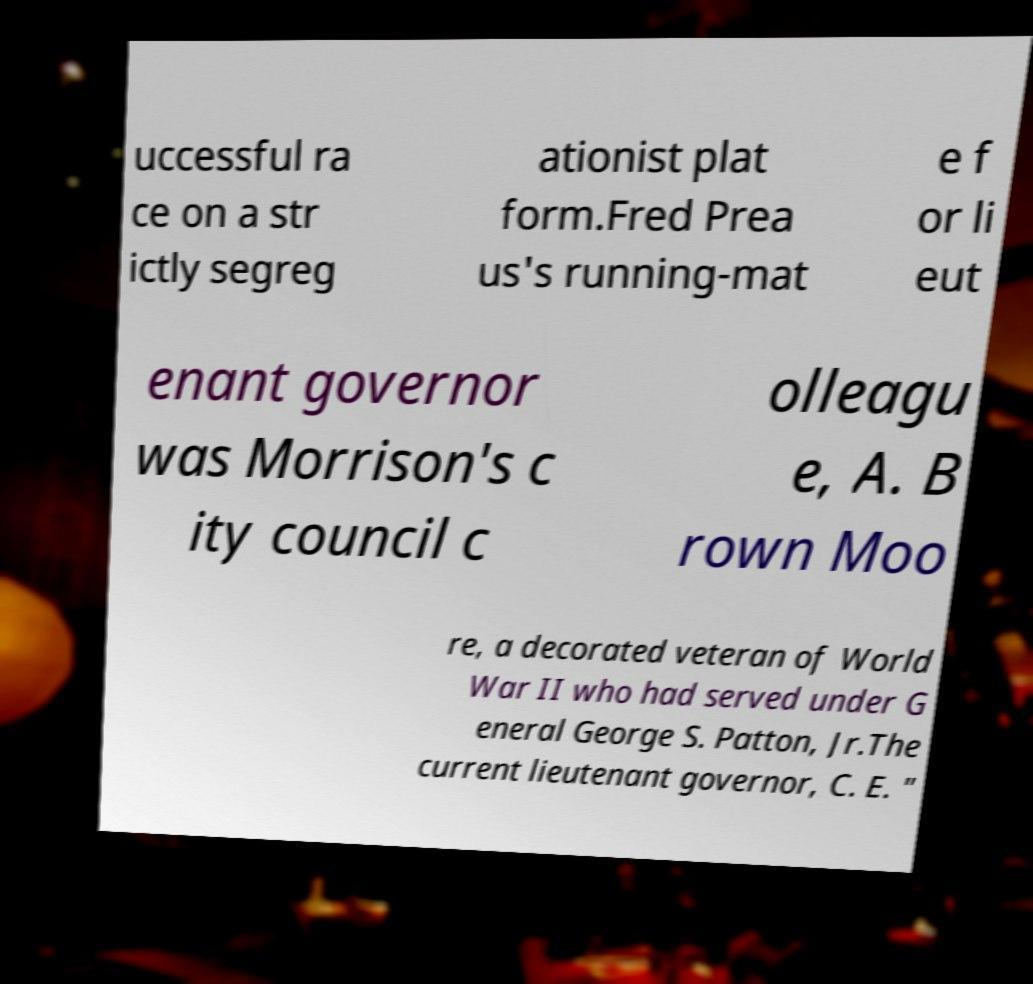For documentation purposes, I need the text within this image transcribed. Could you provide that? uccessful ra ce on a str ictly segreg ationist plat form.Fred Prea us's running-mat e f or li eut enant governor was Morrison's c ity council c olleagu e, A. B rown Moo re, a decorated veteran of World War II who had served under G eneral George S. Patton, Jr.The current lieutenant governor, C. E. " 